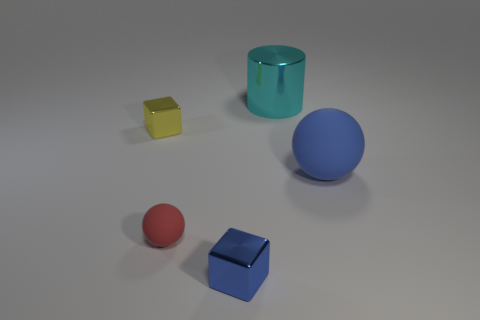What shape is the cyan metal thing? cylinder 